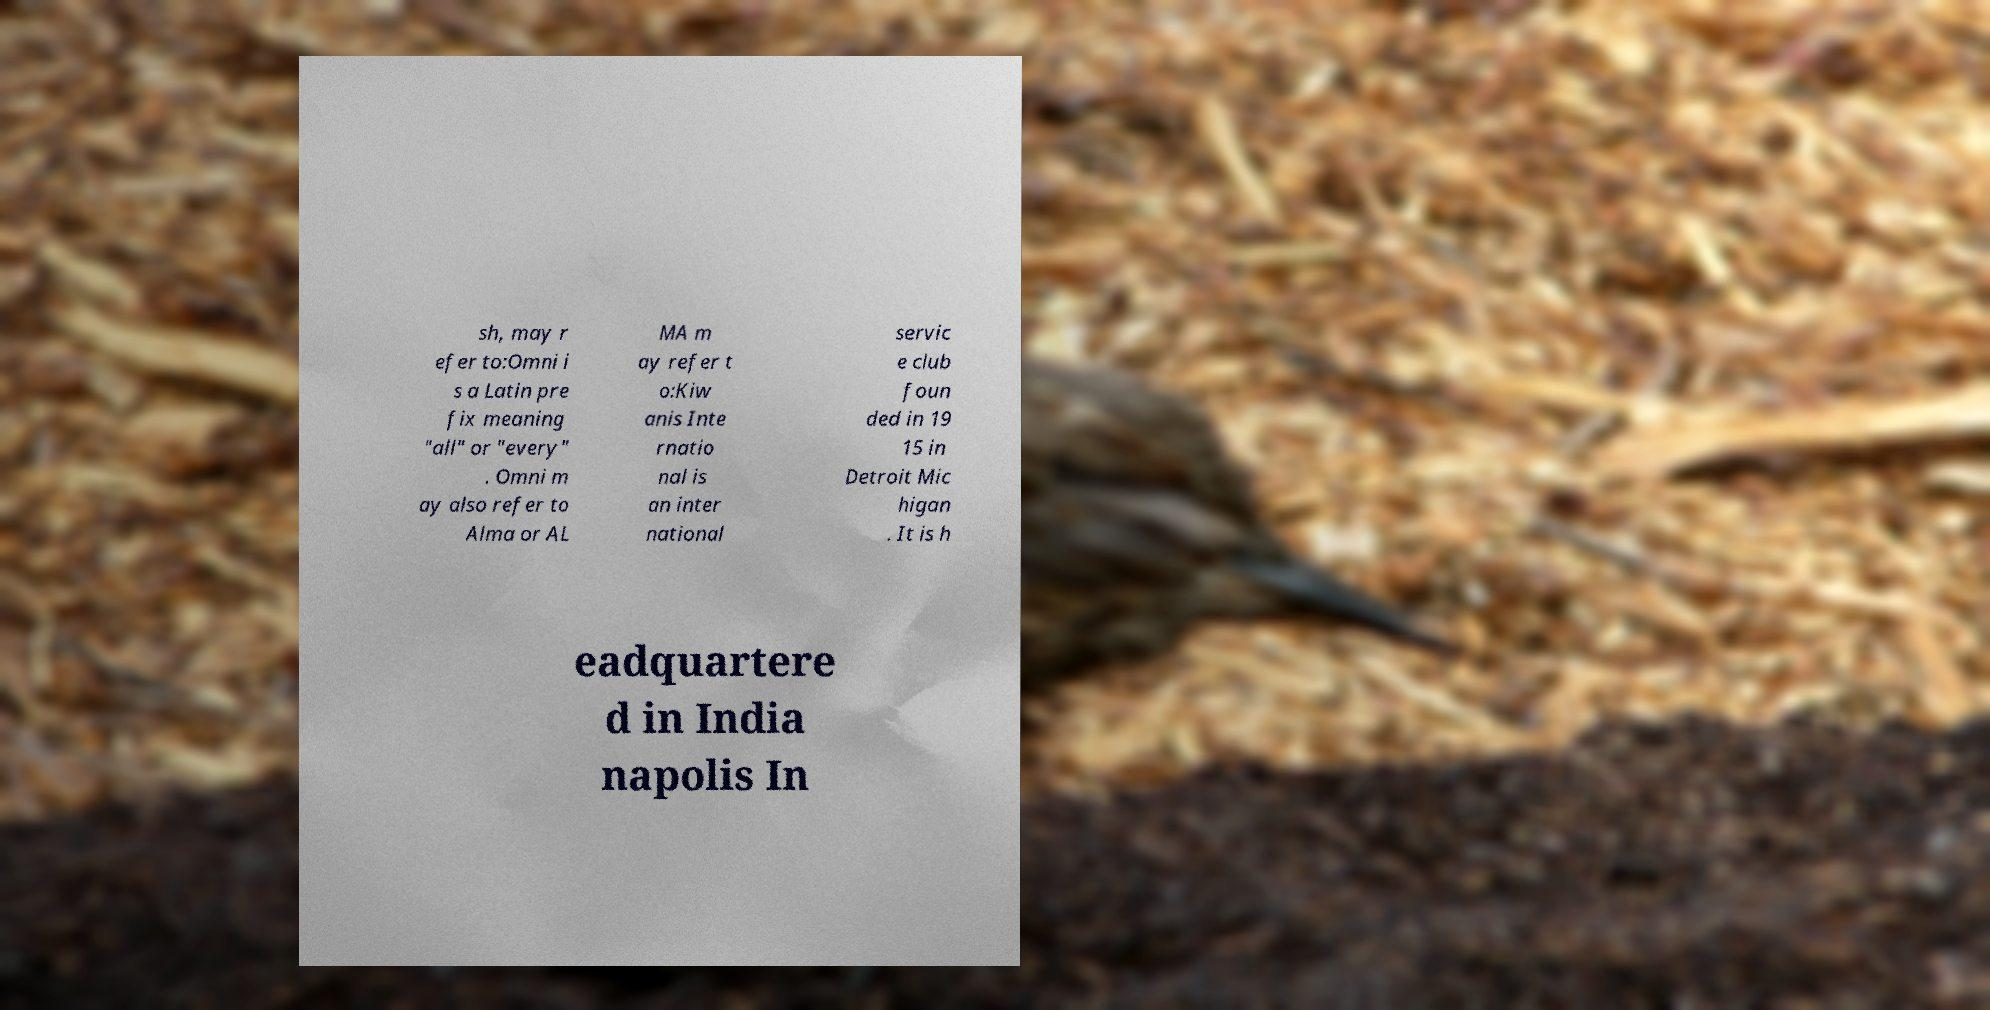Please identify and transcribe the text found in this image. sh, may r efer to:Omni i s a Latin pre fix meaning "all" or "every" . Omni m ay also refer to Alma or AL MA m ay refer t o:Kiw anis Inte rnatio nal is an inter national servic e club foun ded in 19 15 in Detroit Mic higan . It is h eadquartere d in India napolis In 